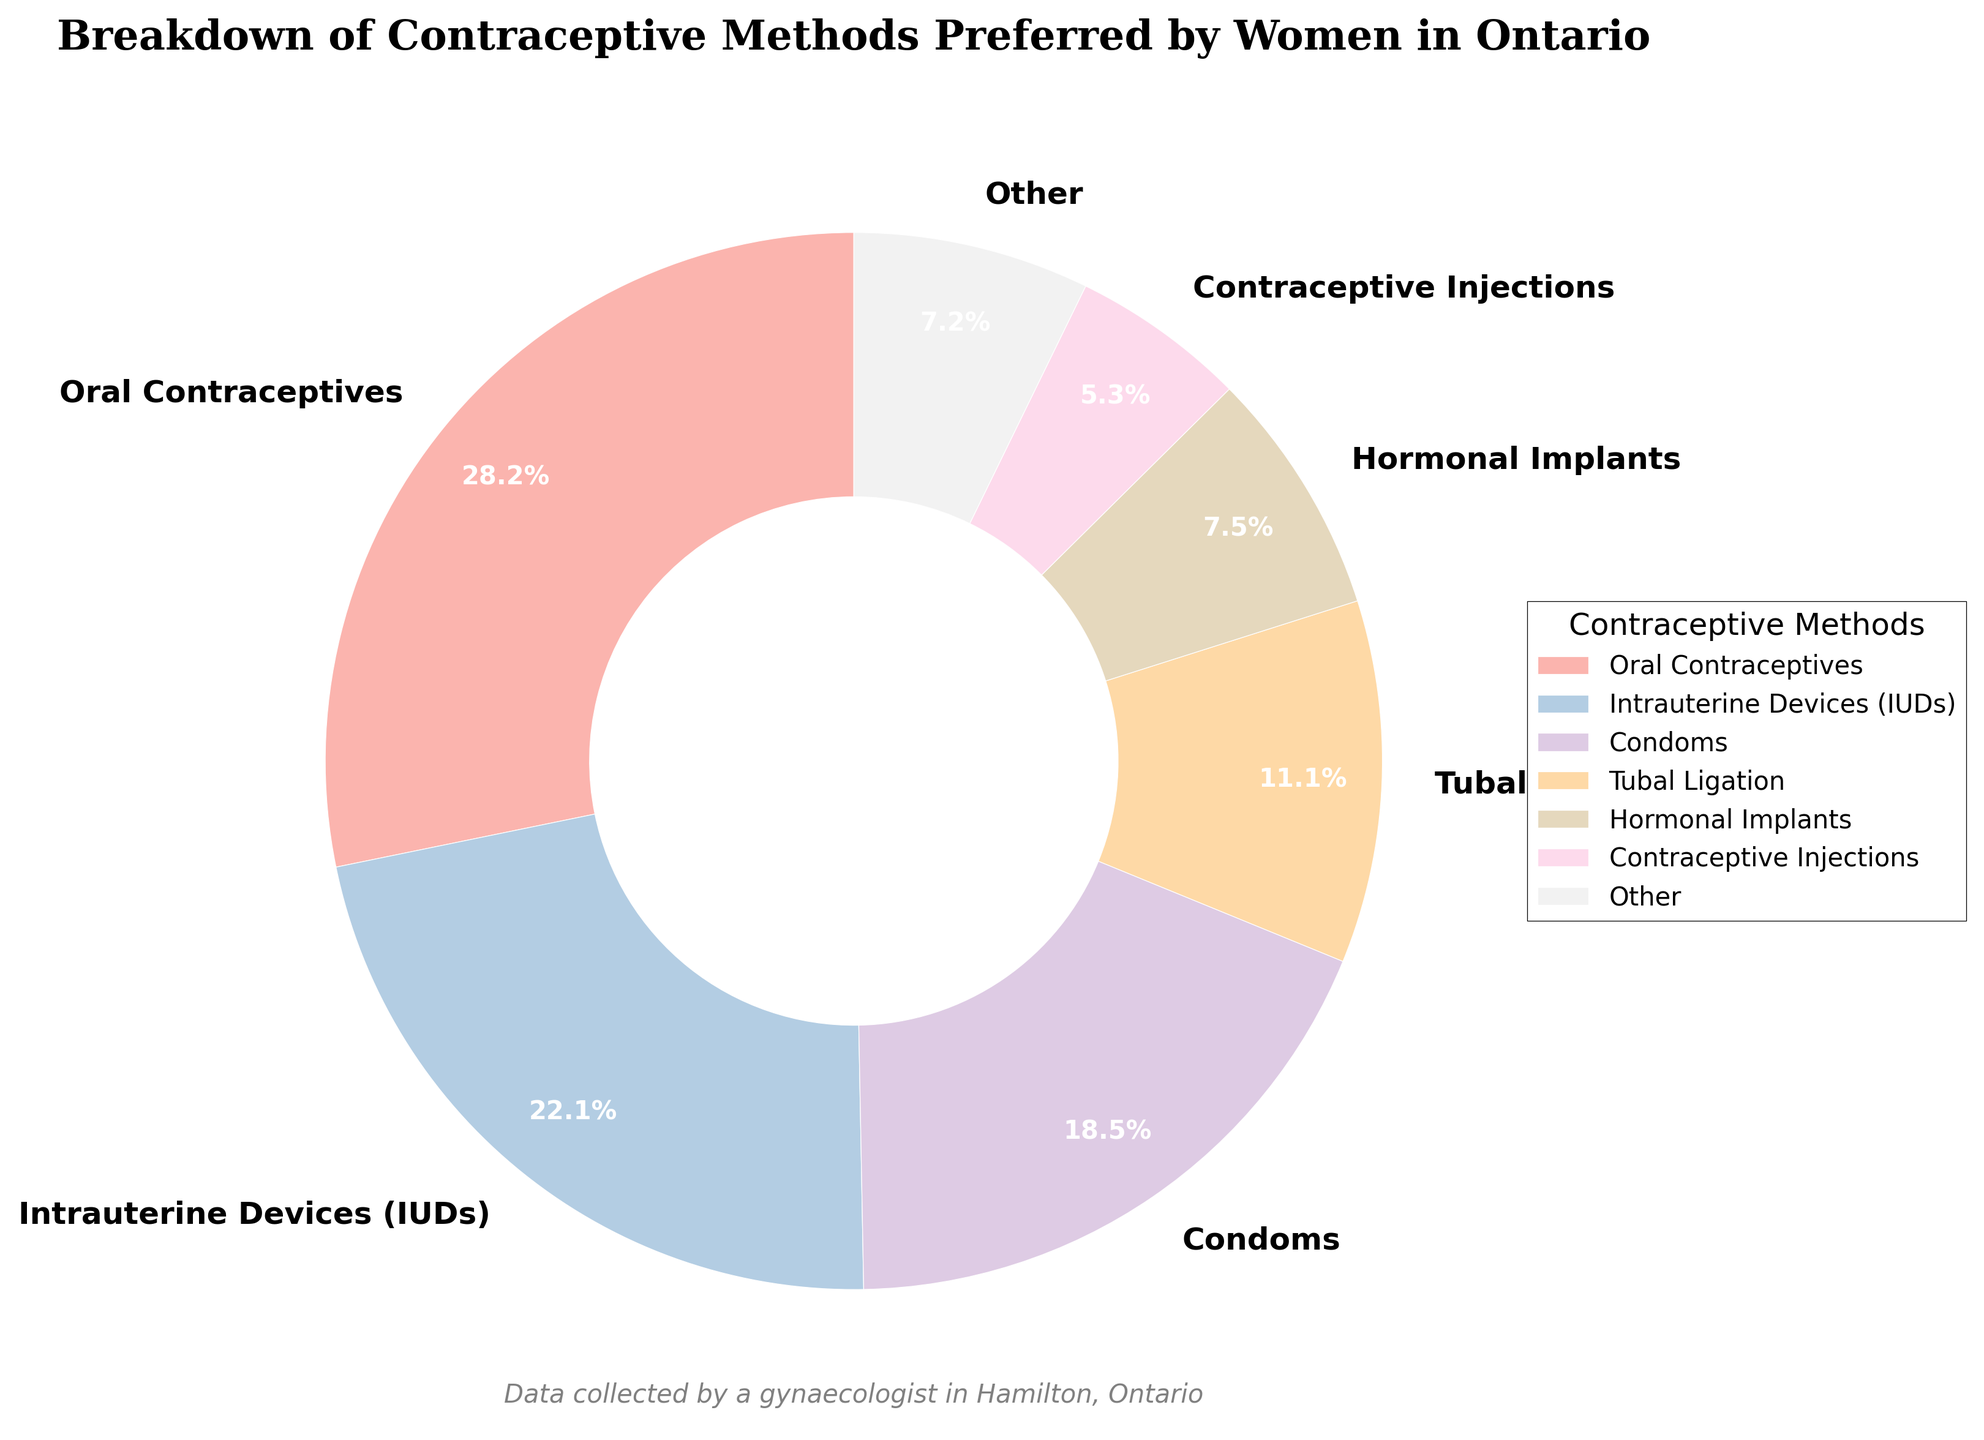Which contraceptive method is most preferred by women in Ontario? The pie chart shows that the segment with the largest percentage represents the most preferred method. Oral Contraceptives have the largest percentage with 28.5%.
Answer: Oral Contraceptives Which method is preferred by more women: condoms or intrauterine devices (IUDs)? Compare the percentages of both methods in the chart. Condoms have 18.7% while IUDs have 22.3%. Therefore, IUDs are more preferred.
Answer: Intrauterine Devices (IUDs) What percentage of women prefer methods categorized as 'Other'? The pie chart includes a category labeled 'Other,' which represents methods with less than 5% usage. This segment sums up the percentages of all less preferred methods: 0.2% + 0.5% + 0.8% + 1.9% + (all methods < 5%).
Answer: 5.3% How do the preferences for contraceptive injections and hormonal implants compare? Locate the segments for both methods. Contraceptive injections have 5.4% and hormonal implants have 7.6%. Therefore, hormonal implants are more preferred than contraceptive injections.
Answer: Hormonal Implants What is the combined percentage of women who prefer tubal ligation and vaginal rings? Sum the percentages of both methods: Tubal Ligation (11.2%) + Vaginal Ring (3.8%) = 15%.
Answer: 15% Which method shows the least preference among women and what is its percentage? The smallest segment in the pie chart represents the least preferred method. The smallest segment is 'Other Methods' with a percentage of 0.1%.
Answer: Other Methods, 0.1% By how much does the preference for condoms exceed the preference for contraceptive injections? Determine the difference between the percentages: Condoms (18.7%) - Contraceptive Injections (5.4%) = 13.3%.
Answer: 13.3% Which methods fall under the category 'Other' and what is the combined percentage for these methods? Identify methods with less than 5% preference: Spermicides (0.2%), Contraceptive Patch (0.5%), Diaphragm (0.8%), Fertility Awareness Methods (1.9%) sum to an 'Other' percentage of 3.4%.
Answer: 3.4% What is the second most preferred contraceptive method? After Oral Contraceptives, the segment with the next largest percentage is analyzed. Intrauterine Devices (IUDs) have the second highest percentage with 22.3%.
Answer: Intrauterine Devices (IUDs) How does the visual representation of methods preferred by at least 5% compare to those less preferred (categorized as 'Other')? Methods with percentages at least 5% are shown individually and contrasted with the 'Other' category, summing methods under 5%. The 'Other' section combines into a single segment, visually smaller than any individual method preferred by at least 5%.
Answer: Visual representation confirms 'Other' is much smaller 